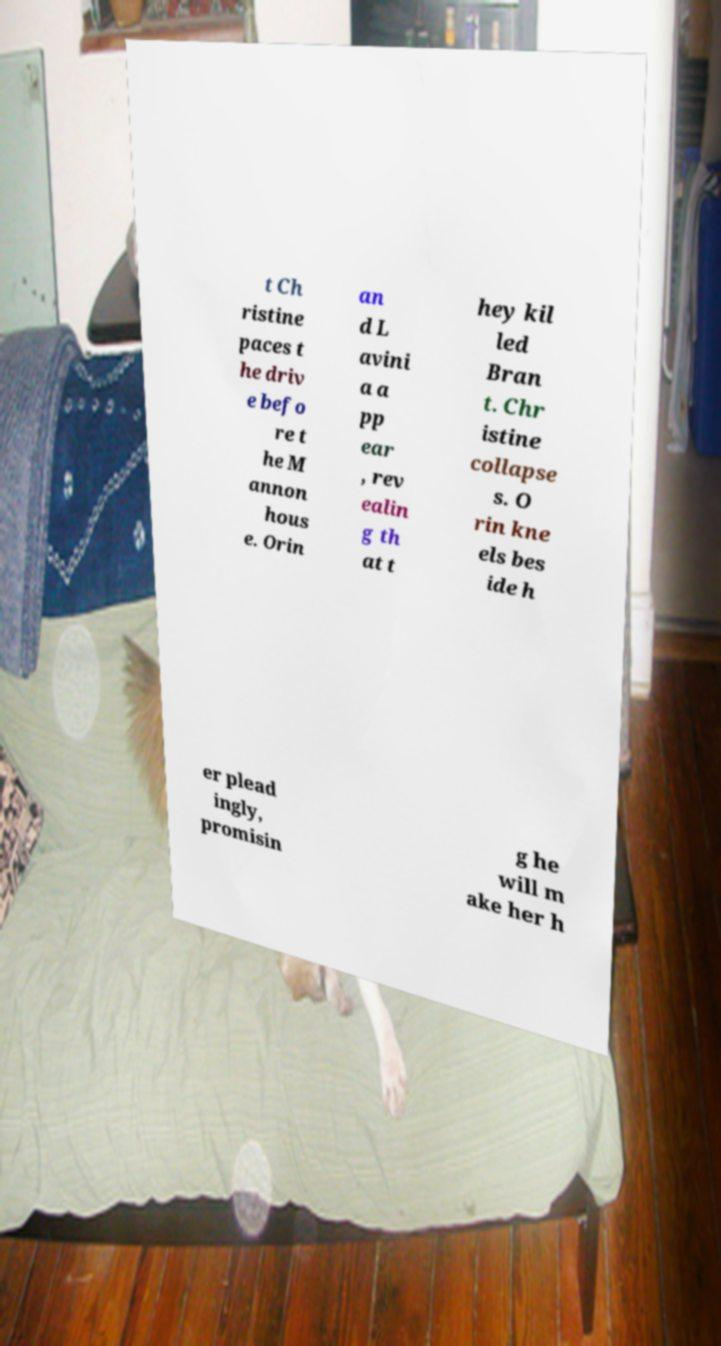Please identify and transcribe the text found in this image. t Ch ristine paces t he driv e befo re t he M annon hous e. Orin an d L avini a a pp ear , rev ealin g th at t hey kil led Bran t. Chr istine collapse s. O rin kne els bes ide h er plead ingly, promisin g he will m ake her h 